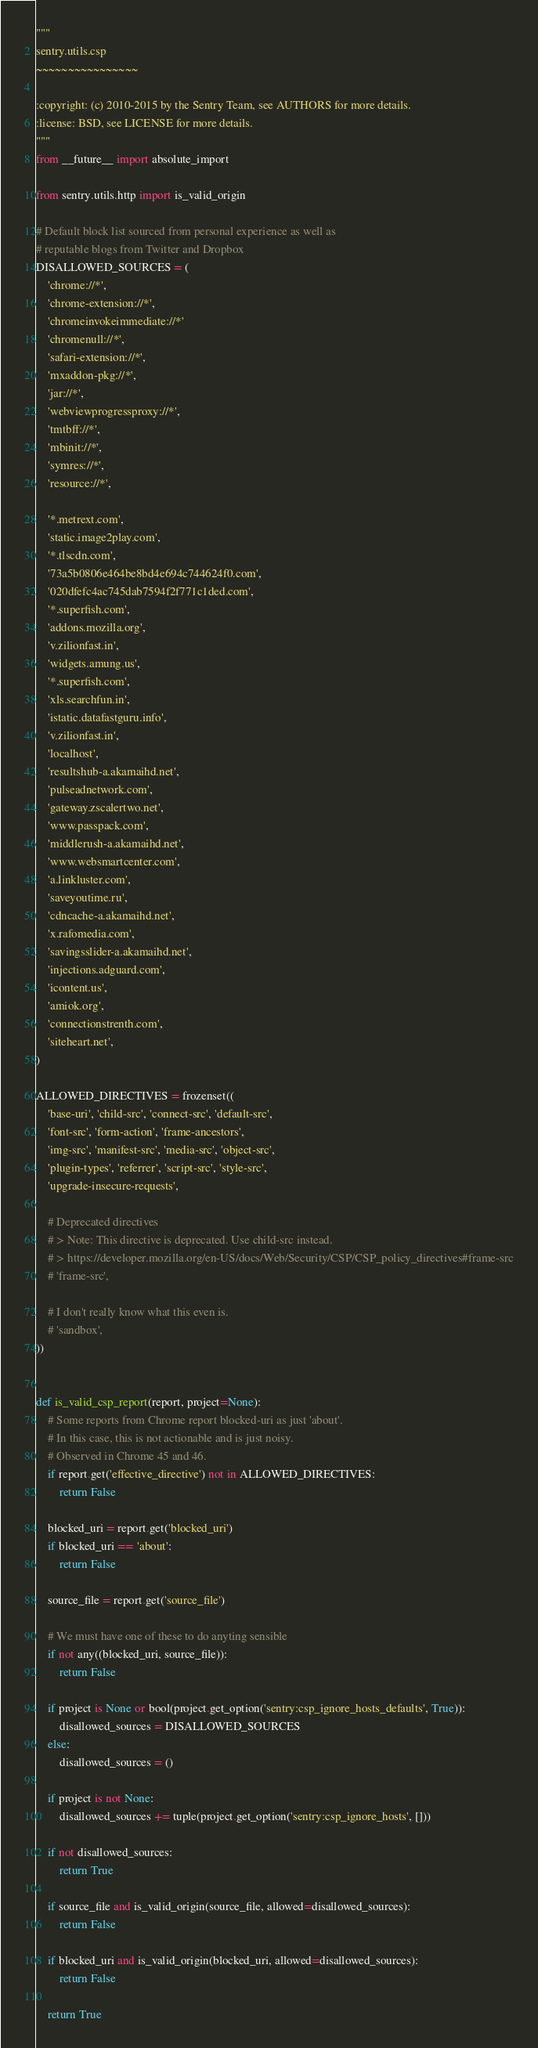Convert code to text. <code><loc_0><loc_0><loc_500><loc_500><_Python_>"""
sentry.utils.csp
~~~~~~~~~~~~~~~~

:copyright: (c) 2010-2015 by the Sentry Team, see AUTHORS for more details.
:license: BSD, see LICENSE for more details.
"""
from __future__ import absolute_import

from sentry.utils.http import is_valid_origin

# Default block list sourced from personal experience as well as
# reputable blogs from Twitter and Dropbox
DISALLOWED_SOURCES = (
    'chrome://*',
    'chrome-extension://*',
    'chromeinvokeimmediate://*'
    'chromenull://*',
    'safari-extension://*',
    'mxaddon-pkg://*',
    'jar://*',
    'webviewprogressproxy://*',
    'tmtbff://*',
    'mbinit://*',
    'symres://*',
    'resource://*',

    '*.metrext.com',
    'static.image2play.com',
    '*.tlscdn.com',
    '73a5b0806e464be8bd4e694c744624f0.com',
    '020dfefc4ac745dab7594f2f771c1ded.com',
    '*.superfish.com',
    'addons.mozilla.org',
    'v.zilionfast.in',
    'widgets.amung.us',
    '*.superfish.com',
    'xls.searchfun.in',
    'istatic.datafastguru.info',
    'v.zilionfast.in',
    'localhost',
    'resultshub-a.akamaihd.net',
    'pulseadnetwork.com',
    'gateway.zscalertwo.net',
    'www.passpack.com',
    'middlerush-a.akamaihd.net',
    'www.websmartcenter.com',
    'a.linkluster.com',
    'saveyoutime.ru',
    'cdncache-a.akamaihd.net',
    'x.rafomedia.com',
    'savingsslider-a.akamaihd.net',
    'injections.adguard.com',
    'icontent.us',
    'amiok.org',
    'connectionstrenth.com',
    'siteheart.net',
)

ALLOWED_DIRECTIVES = frozenset((
    'base-uri', 'child-src', 'connect-src', 'default-src',
    'font-src', 'form-action', 'frame-ancestors',
    'img-src', 'manifest-src', 'media-src', 'object-src',
    'plugin-types', 'referrer', 'script-src', 'style-src',
    'upgrade-insecure-requests',

    # Deprecated directives
    # > Note: This directive is deprecated. Use child-src instead.
    # > https://developer.mozilla.org/en-US/docs/Web/Security/CSP/CSP_policy_directives#frame-src
    # 'frame-src',

    # I don't really know what this even is.
    # 'sandbox',
))


def is_valid_csp_report(report, project=None):
    # Some reports from Chrome report blocked-uri as just 'about'.
    # In this case, this is not actionable and is just noisy.
    # Observed in Chrome 45 and 46.
    if report.get('effective_directive') not in ALLOWED_DIRECTIVES:
        return False

    blocked_uri = report.get('blocked_uri')
    if blocked_uri == 'about':
        return False

    source_file = report.get('source_file')

    # We must have one of these to do anyting sensible
    if not any((blocked_uri, source_file)):
        return False

    if project is None or bool(project.get_option('sentry:csp_ignore_hosts_defaults', True)):
        disallowed_sources = DISALLOWED_SOURCES
    else:
        disallowed_sources = ()

    if project is not None:
        disallowed_sources += tuple(project.get_option('sentry:csp_ignore_hosts', []))

    if not disallowed_sources:
        return True

    if source_file and is_valid_origin(source_file, allowed=disallowed_sources):
        return False

    if blocked_uri and is_valid_origin(blocked_uri, allowed=disallowed_sources):
        return False

    return True
</code> 